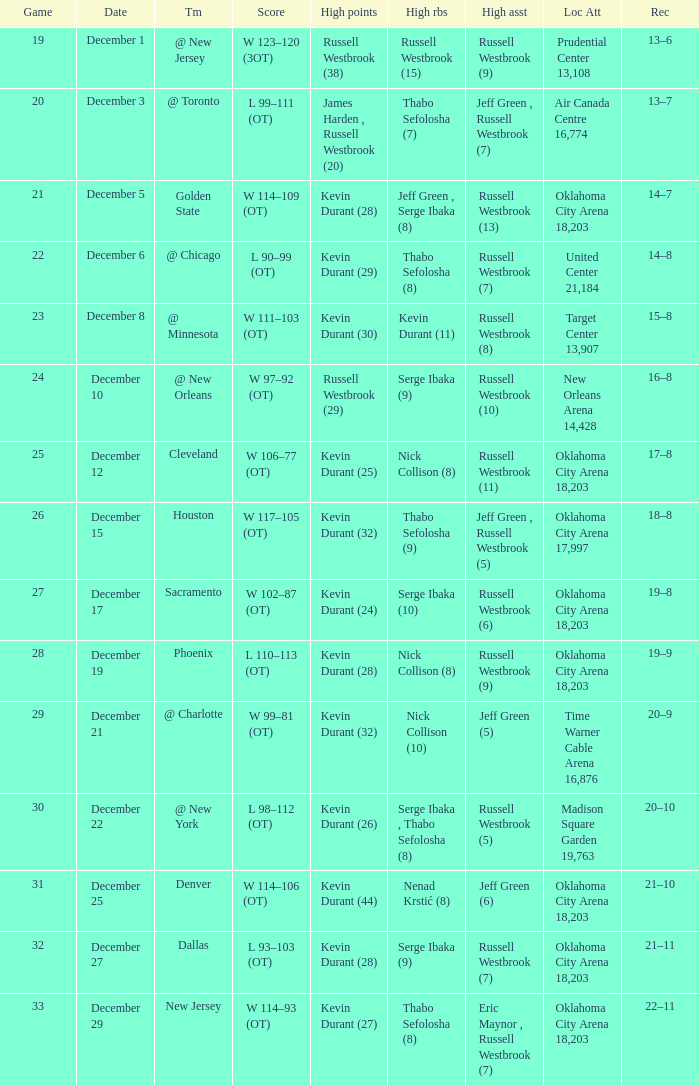What was the record on December 27? 21–11. 